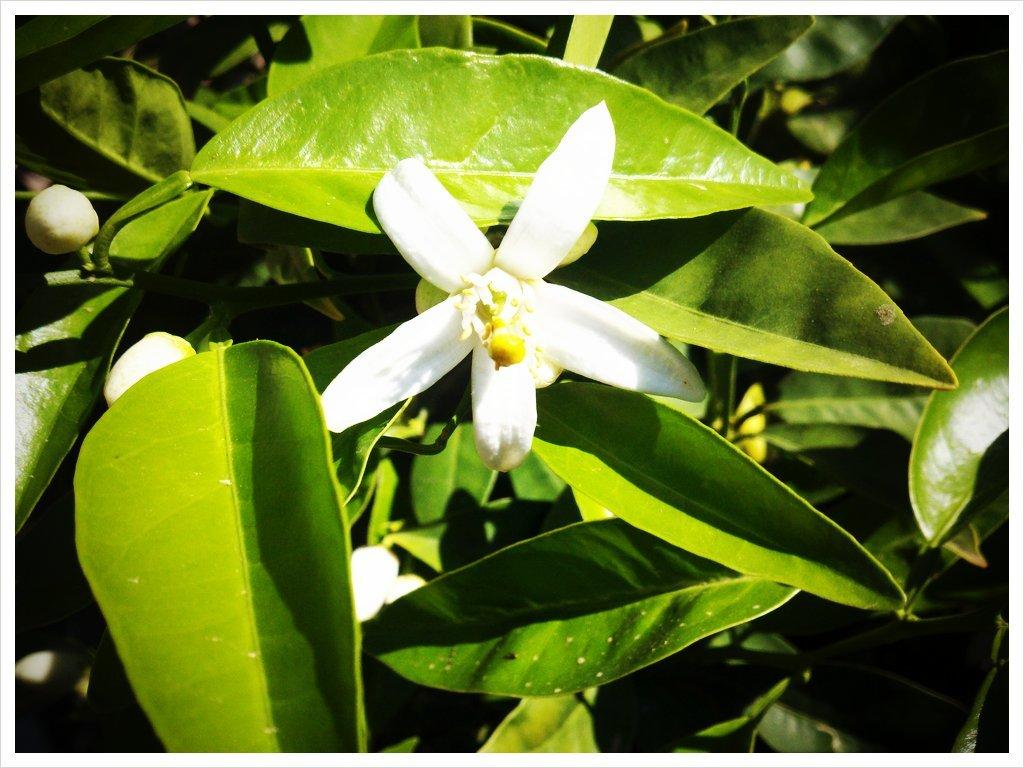What type of living organism can be seen in the image? There is a plant in the image. What specific features can be observed on the plant? There are white flowers and buds on the plant. How would you describe the background of the image? The background of the image is dark. What type of playground equipment can be seen in the image? There is no playground equipment present in the image; it features a plant with white flowers and buds against a dark background. 